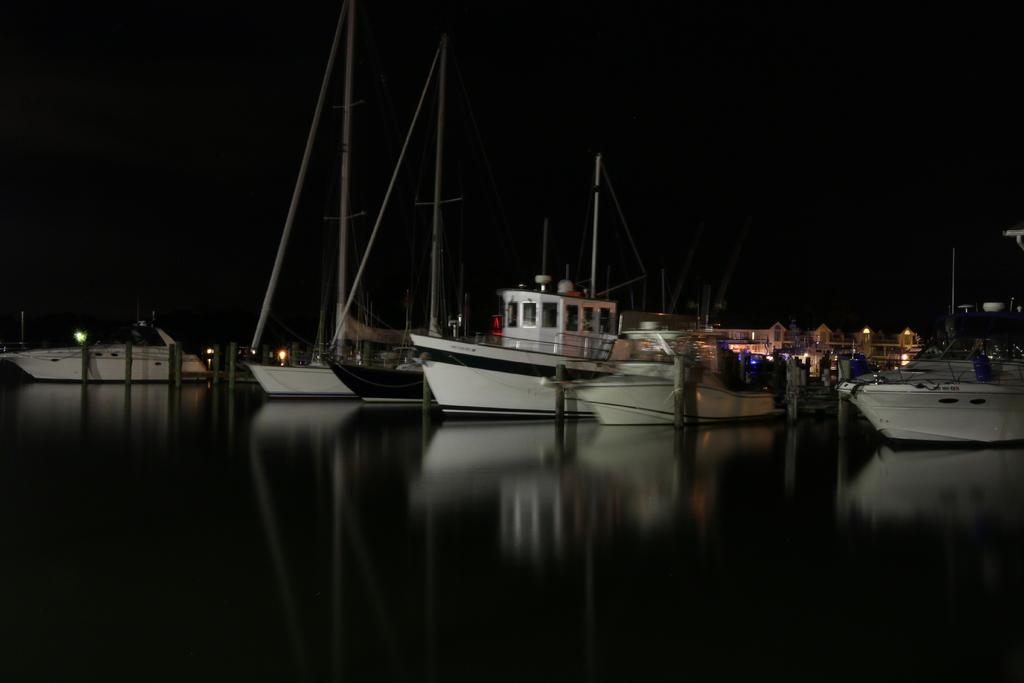What is located at the bottom of the image? There is a river at the bottom of the image. What can be seen in the river? There are boats in the river. What is visible in the background of the image? There are buildings and poles in the background of the image. How many toes are visible on the boats in the image? There are no toes visible in the image, as boats do not have toes. 